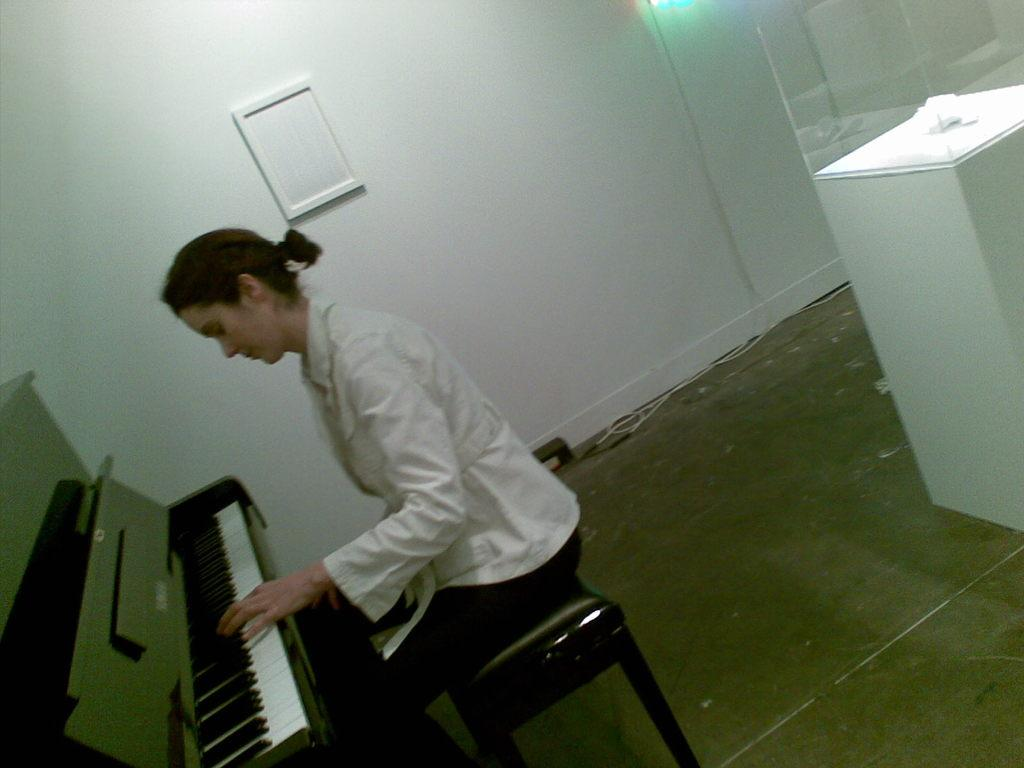Who is the main subject in the image? There is a person in the image. What is the person doing in the image? The person is playing a piano. Where is the person located in the image? The person is sitting on a table. What type of thread is the person using to play the piano in the image? There is no thread present in the image, and the person is not using any thread to play the piano. 